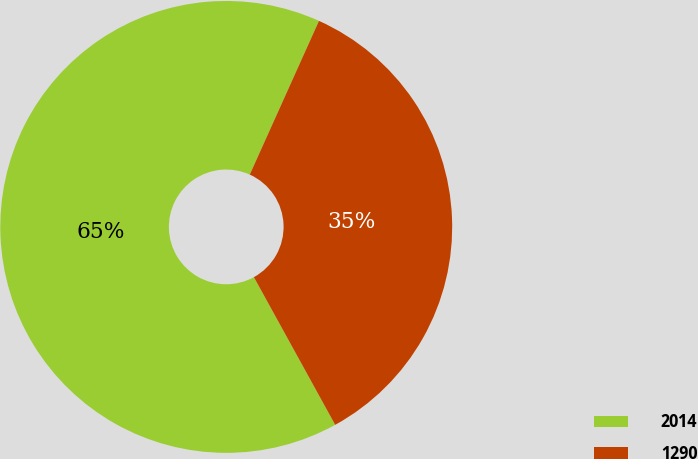Convert chart to OTSL. <chart><loc_0><loc_0><loc_500><loc_500><pie_chart><fcel>2014<fcel>1290<nl><fcel>64.74%<fcel>35.26%<nl></chart> 